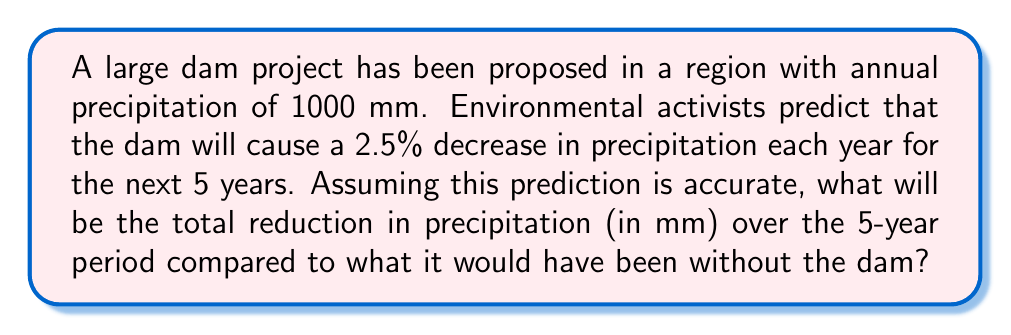Solve this math problem. Let's approach this step-by-step:

1) First, we need to calculate the precipitation for each year:

   Year 0 (current): 1000 mm
   Year 1: $1000 \times (1 - 0.025) = 1000 \times 0.975 = 975$ mm
   Year 2: $975 \times 0.975 = 950.625$ mm
   Year 3: $950.625 \times 0.975 = 926.859375$ mm
   Year 4: $926.859375 \times 0.975 = 903.6878906$ mm
   Year 5: $903.6878906 \times 0.975 = 881.0956934$ mm

2) Now, let's sum up the precipitation for all 5 years with the dam:

   $975 + 950.625 + 926.859375 + 903.6878906 + 881.0956934 = 4637.267959$ mm

3) Without the dam, the precipitation would have remained constant at 1000 mm per year:

   $1000 \times 5 = 5000$ mm

4) The total reduction is the difference between these two values:

   $5000 - 4637.267959 = 362.732041$ mm

Therefore, the total reduction in precipitation over the 5-year period is approximately 362.73 mm.
Answer: 362.73 mm 